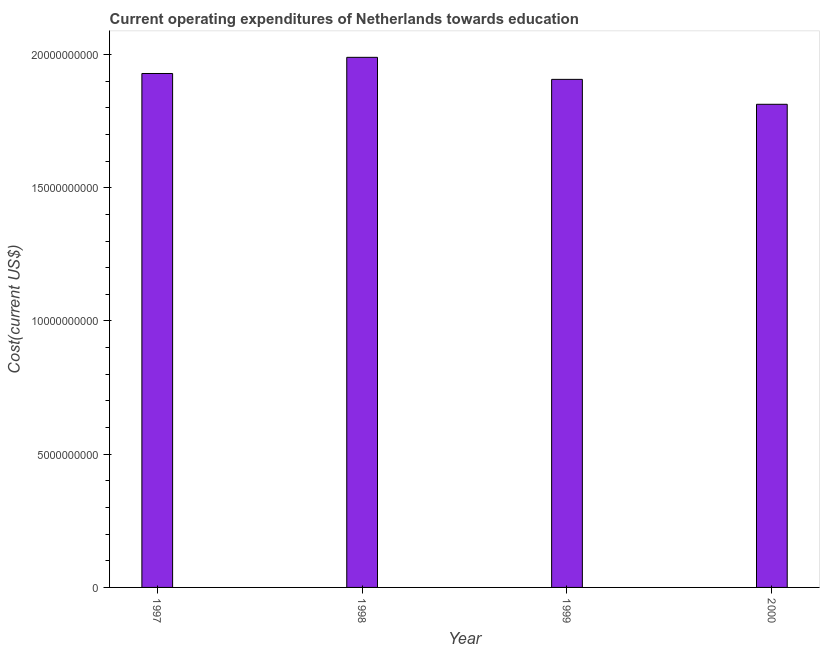Does the graph contain any zero values?
Your response must be concise. No. What is the title of the graph?
Provide a succinct answer. Current operating expenditures of Netherlands towards education. What is the label or title of the X-axis?
Give a very brief answer. Year. What is the label or title of the Y-axis?
Your response must be concise. Cost(current US$). What is the education expenditure in 2000?
Your answer should be very brief. 1.81e+1. Across all years, what is the maximum education expenditure?
Make the answer very short. 1.99e+1. Across all years, what is the minimum education expenditure?
Provide a succinct answer. 1.81e+1. In which year was the education expenditure minimum?
Make the answer very short. 2000. What is the sum of the education expenditure?
Your answer should be very brief. 7.64e+1. What is the difference between the education expenditure in 1997 and 2000?
Offer a terse response. 1.16e+09. What is the average education expenditure per year?
Make the answer very short. 1.91e+1. What is the median education expenditure?
Offer a terse response. 1.92e+1. In how many years, is the education expenditure greater than 8000000000 US$?
Provide a short and direct response. 4. Do a majority of the years between 1998 and 2000 (inclusive) have education expenditure greater than 9000000000 US$?
Provide a short and direct response. Yes. What is the ratio of the education expenditure in 1998 to that in 1999?
Make the answer very short. 1.04. Is the education expenditure in 1998 less than that in 2000?
Provide a short and direct response. No. Is the difference between the education expenditure in 1997 and 1998 greater than the difference between any two years?
Your answer should be very brief. No. What is the difference between the highest and the second highest education expenditure?
Provide a short and direct response. 6.07e+08. Is the sum of the education expenditure in 1998 and 1999 greater than the maximum education expenditure across all years?
Make the answer very short. Yes. What is the difference between the highest and the lowest education expenditure?
Make the answer very short. 1.76e+09. In how many years, is the education expenditure greater than the average education expenditure taken over all years?
Keep it short and to the point. 2. How many bars are there?
Your answer should be very brief. 4. How many years are there in the graph?
Offer a terse response. 4. What is the Cost(current US$) in 1997?
Your response must be concise. 1.93e+1. What is the Cost(current US$) of 1998?
Provide a succinct answer. 1.99e+1. What is the Cost(current US$) in 1999?
Provide a short and direct response. 1.91e+1. What is the Cost(current US$) in 2000?
Your answer should be compact. 1.81e+1. What is the difference between the Cost(current US$) in 1997 and 1998?
Your response must be concise. -6.07e+08. What is the difference between the Cost(current US$) in 1997 and 1999?
Keep it short and to the point. 2.20e+08. What is the difference between the Cost(current US$) in 1997 and 2000?
Ensure brevity in your answer.  1.16e+09. What is the difference between the Cost(current US$) in 1998 and 1999?
Ensure brevity in your answer.  8.27e+08. What is the difference between the Cost(current US$) in 1998 and 2000?
Ensure brevity in your answer.  1.76e+09. What is the difference between the Cost(current US$) in 1999 and 2000?
Your response must be concise. 9.35e+08. What is the ratio of the Cost(current US$) in 1997 to that in 1999?
Provide a short and direct response. 1.01. What is the ratio of the Cost(current US$) in 1997 to that in 2000?
Keep it short and to the point. 1.06. What is the ratio of the Cost(current US$) in 1998 to that in 1999?
Provide a short and direct response. 1.04. What is the ratio of the Cost(current US$) in 1998 to that in 2000?
Provide a short and direct response. 1.1. What is the ratio of the Cost(current US$) in 1999 to that in 2000?
Keep it short and to the point. 1.05. 